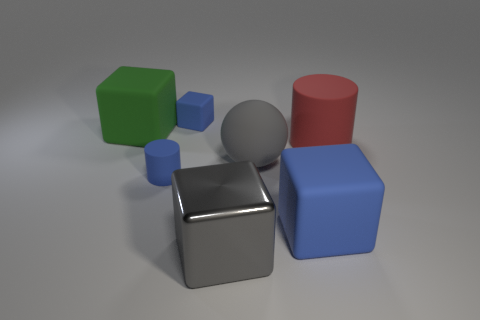Is there any other thing that is made of the same material as the big gray cube?
Your answer should be compact. No. Are there any blue rubber cylinders of the same size as the metal thing?
Your response must be concise. No. There is a object that is both on the left side of the small blue rubber block and behind the red matte object; what material is it made of?
Your response must be concise. Rubber. What number of rubber things are either big red objects or large gray objects?
Ensure brevity in your answer.  2. There is a tiny thing that is the same material as the tiny blue block; what shape is it?
Provide a short and direct response. Cylinder. How many blue rubber things are both in front of the blue rubber cylinder and to the left of the gray metallic object?
Provide a succinct answer. 0. Is there anything else that is the same shape as the large gray rubber thing?
Your answer should be compact. No. What is the size of the rubber object in front of the small matte cylinder?
Your answer should be compact. Large. How many other things are the same color as the metal block?
Provide a succinct answer. 1. What is the material of the small thing that is in front of the blue cube behind the big blue object?
Your answer should be very brief. Rubber. 